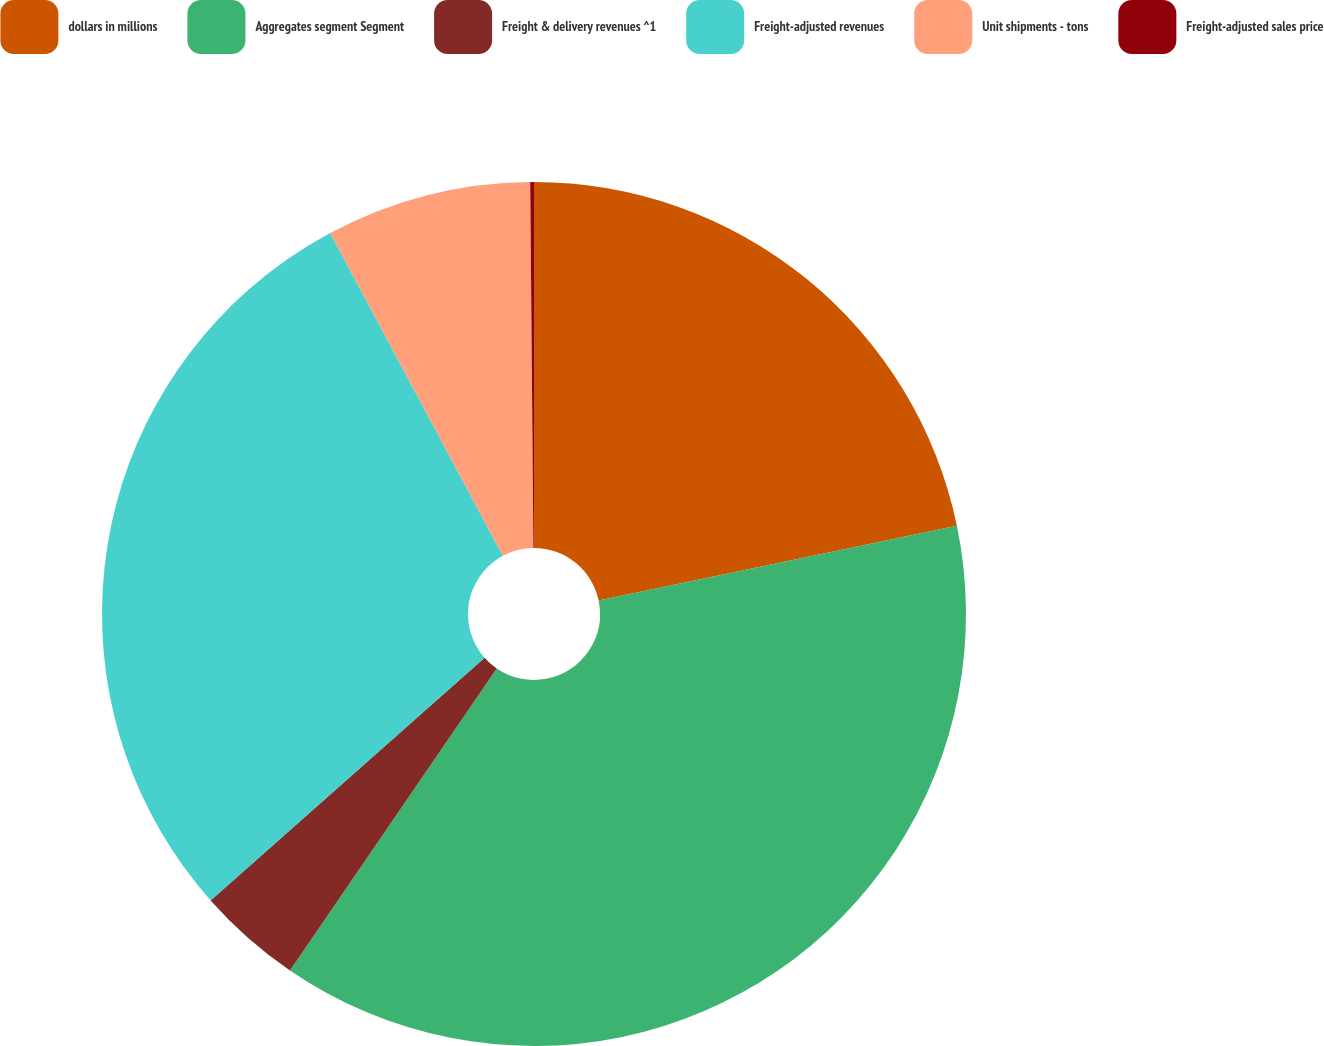Convert chart to OTSL. <chart><loc_0><loc_0><loc_500><loc_500><pie_chart><fcel>dollars in millions<fcel>Aggregates segment Segment<fcel>Freight & delivery revenues ^1<fcel>Freight-adjusted revenues<fcel>Unit shipments - tons<fcel>Freight-adjusted sales price<nl><fcel>21.73%<fcel>37.83%<fcel>3.91%<fcel>28.72%<fcel>7.68%<fcel>0.14%<nl></chart> 